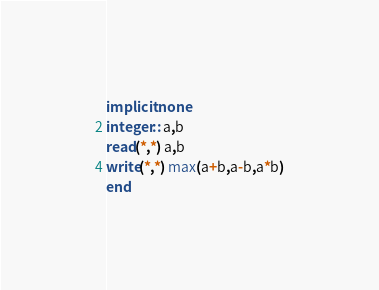<code> <loc_0><loc_0><loc_500><loc_500><_FORTRAN_>implicit none
integer:: a,b
read(*,*) a,b
write(*,*) max(a+b,a-b,a*b)
end</code> 